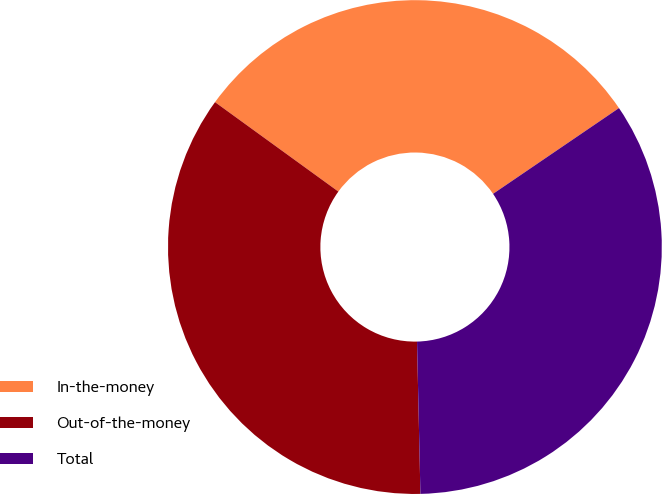Convert chart. <chart><loc_0><loc_0><loc_500><loc_500><pie_chart><fcel>In-the-money<fcel>Out-of-the-money<fcel>Total<nl><fcel>30.5%<fcel>35.34%<fcel>34.16%<nl></chart> 